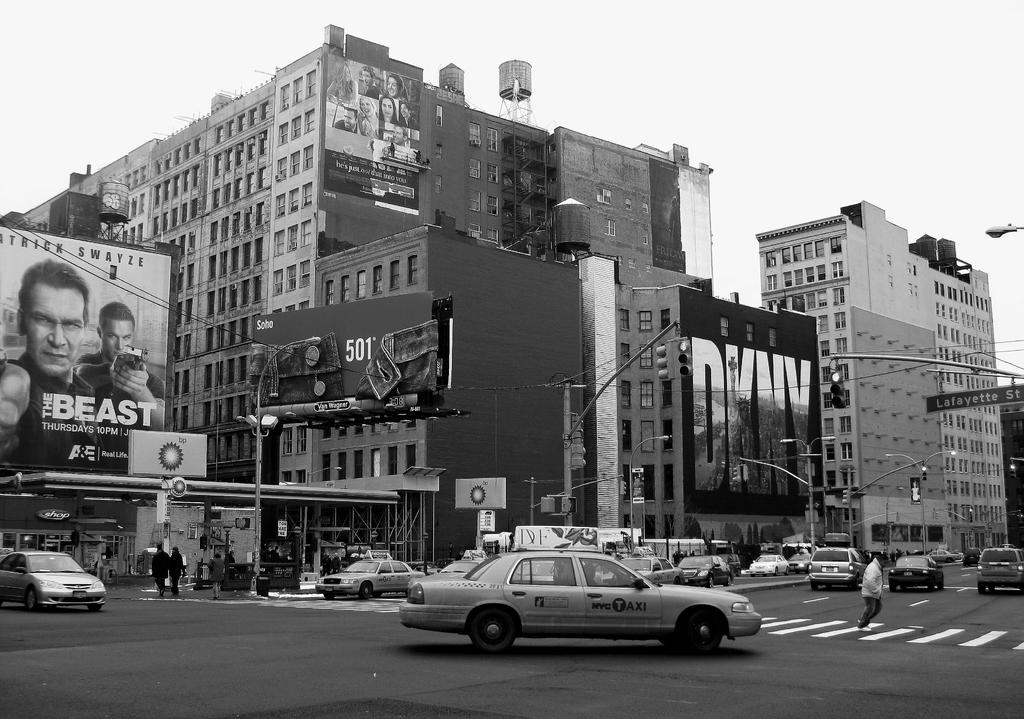<image>
Write a terse but informative summary of the picture. A large advertisement for the television show The Beast is displayed on a New York street. 